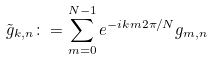Convert formula to latex. <formula><loc_0><loc_0><loc_500><loc_500>\tilde { g } _ { k , n } \colon = \sum _ { m = 0 } ^ { N - 1 } e ^ { - i k m 2 \pi / N } g _ { m , n }</formula> 